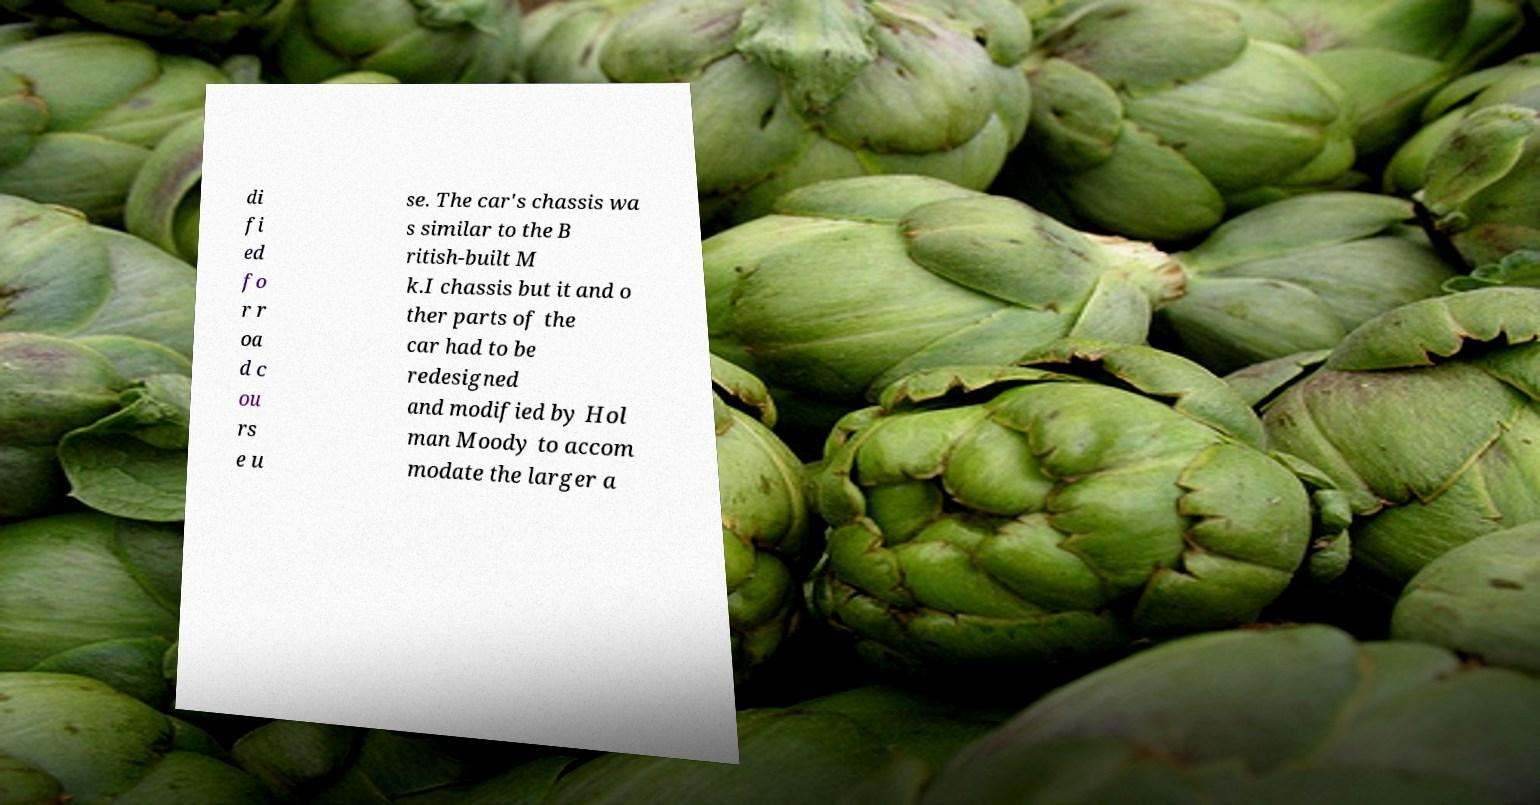Can you accurately transcribe the text from the provided image for me? di fi ed fo r r oa d c ou rs e u se. The car's chassis wa s similar to the B ritish-built M k.I chassis but it and o ther parts of the car had to be redesigned and modified by Hol man Moody to accom modate the larger a 